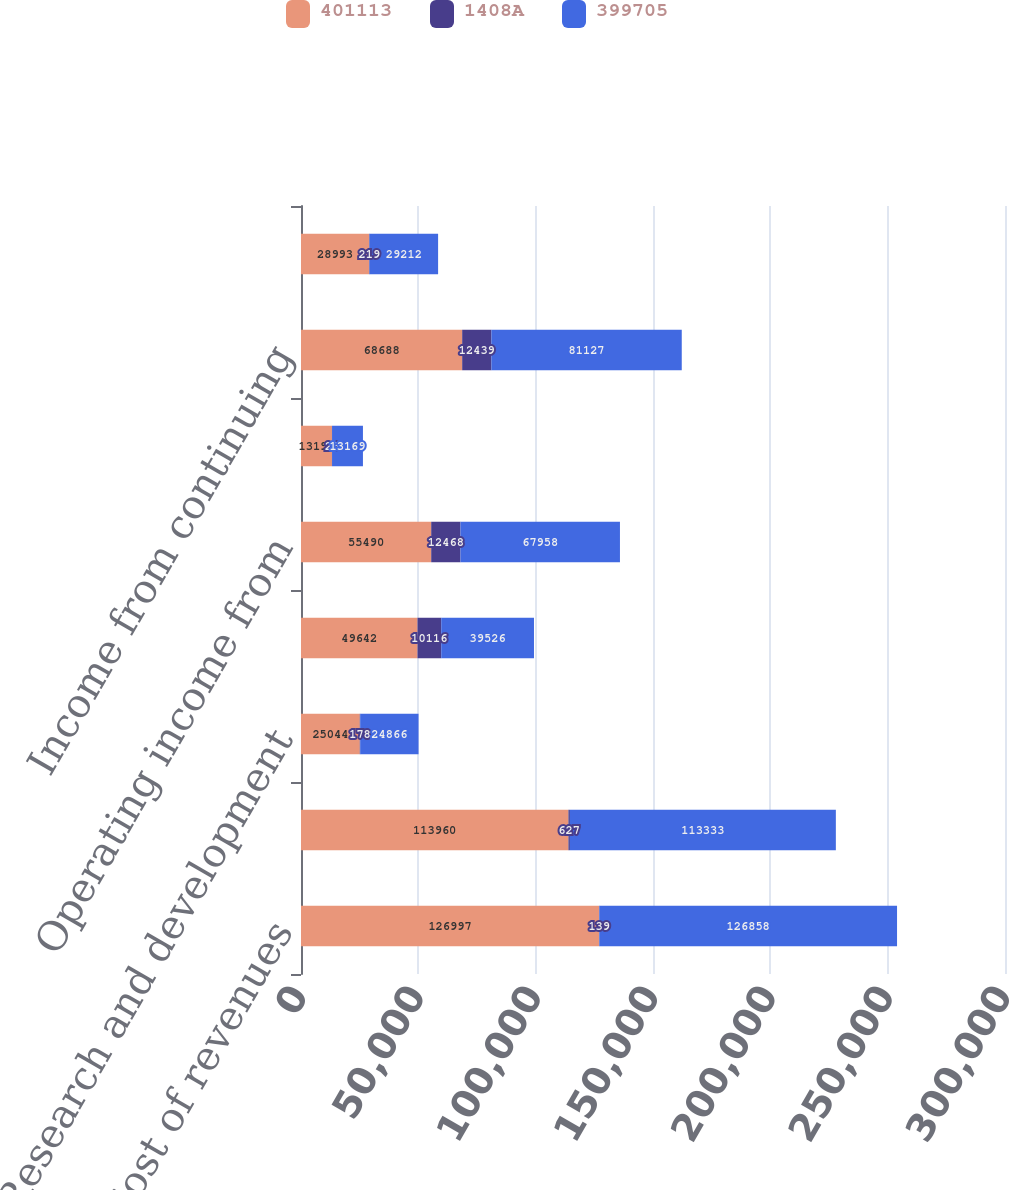Convert chart to OTSL. <chart><loc_0><loc_0><loc_500><loc_500><stacked_bar_chart><ecel><fcel>Cost of revenues<fcel>Sales and marketing<fcel>Research and development<fcel>General and administrative<fcel>Operating income from<fcel>Total other income net<fcel>Income from continuing<fcel>Income tax expense<nl><fcel>401113<fcel>126997<fcel>113960<fcel>25044<fcel>49642<fcel>55490<fcel>13198<fcel>68688<fcel>28993<nl><fcel>1408A<fcel>139<fcel>627<fcel>178<fcel>10116<fcel>12468<fcel>29<fcel>12439<fcel>219<nl><fcel>399705<fcel>126858<fcel>113333<fcel>24866<fcel>39526<fcel>67958<fcel>13169<fcel>81127<fcel>29212<nl></chart> 